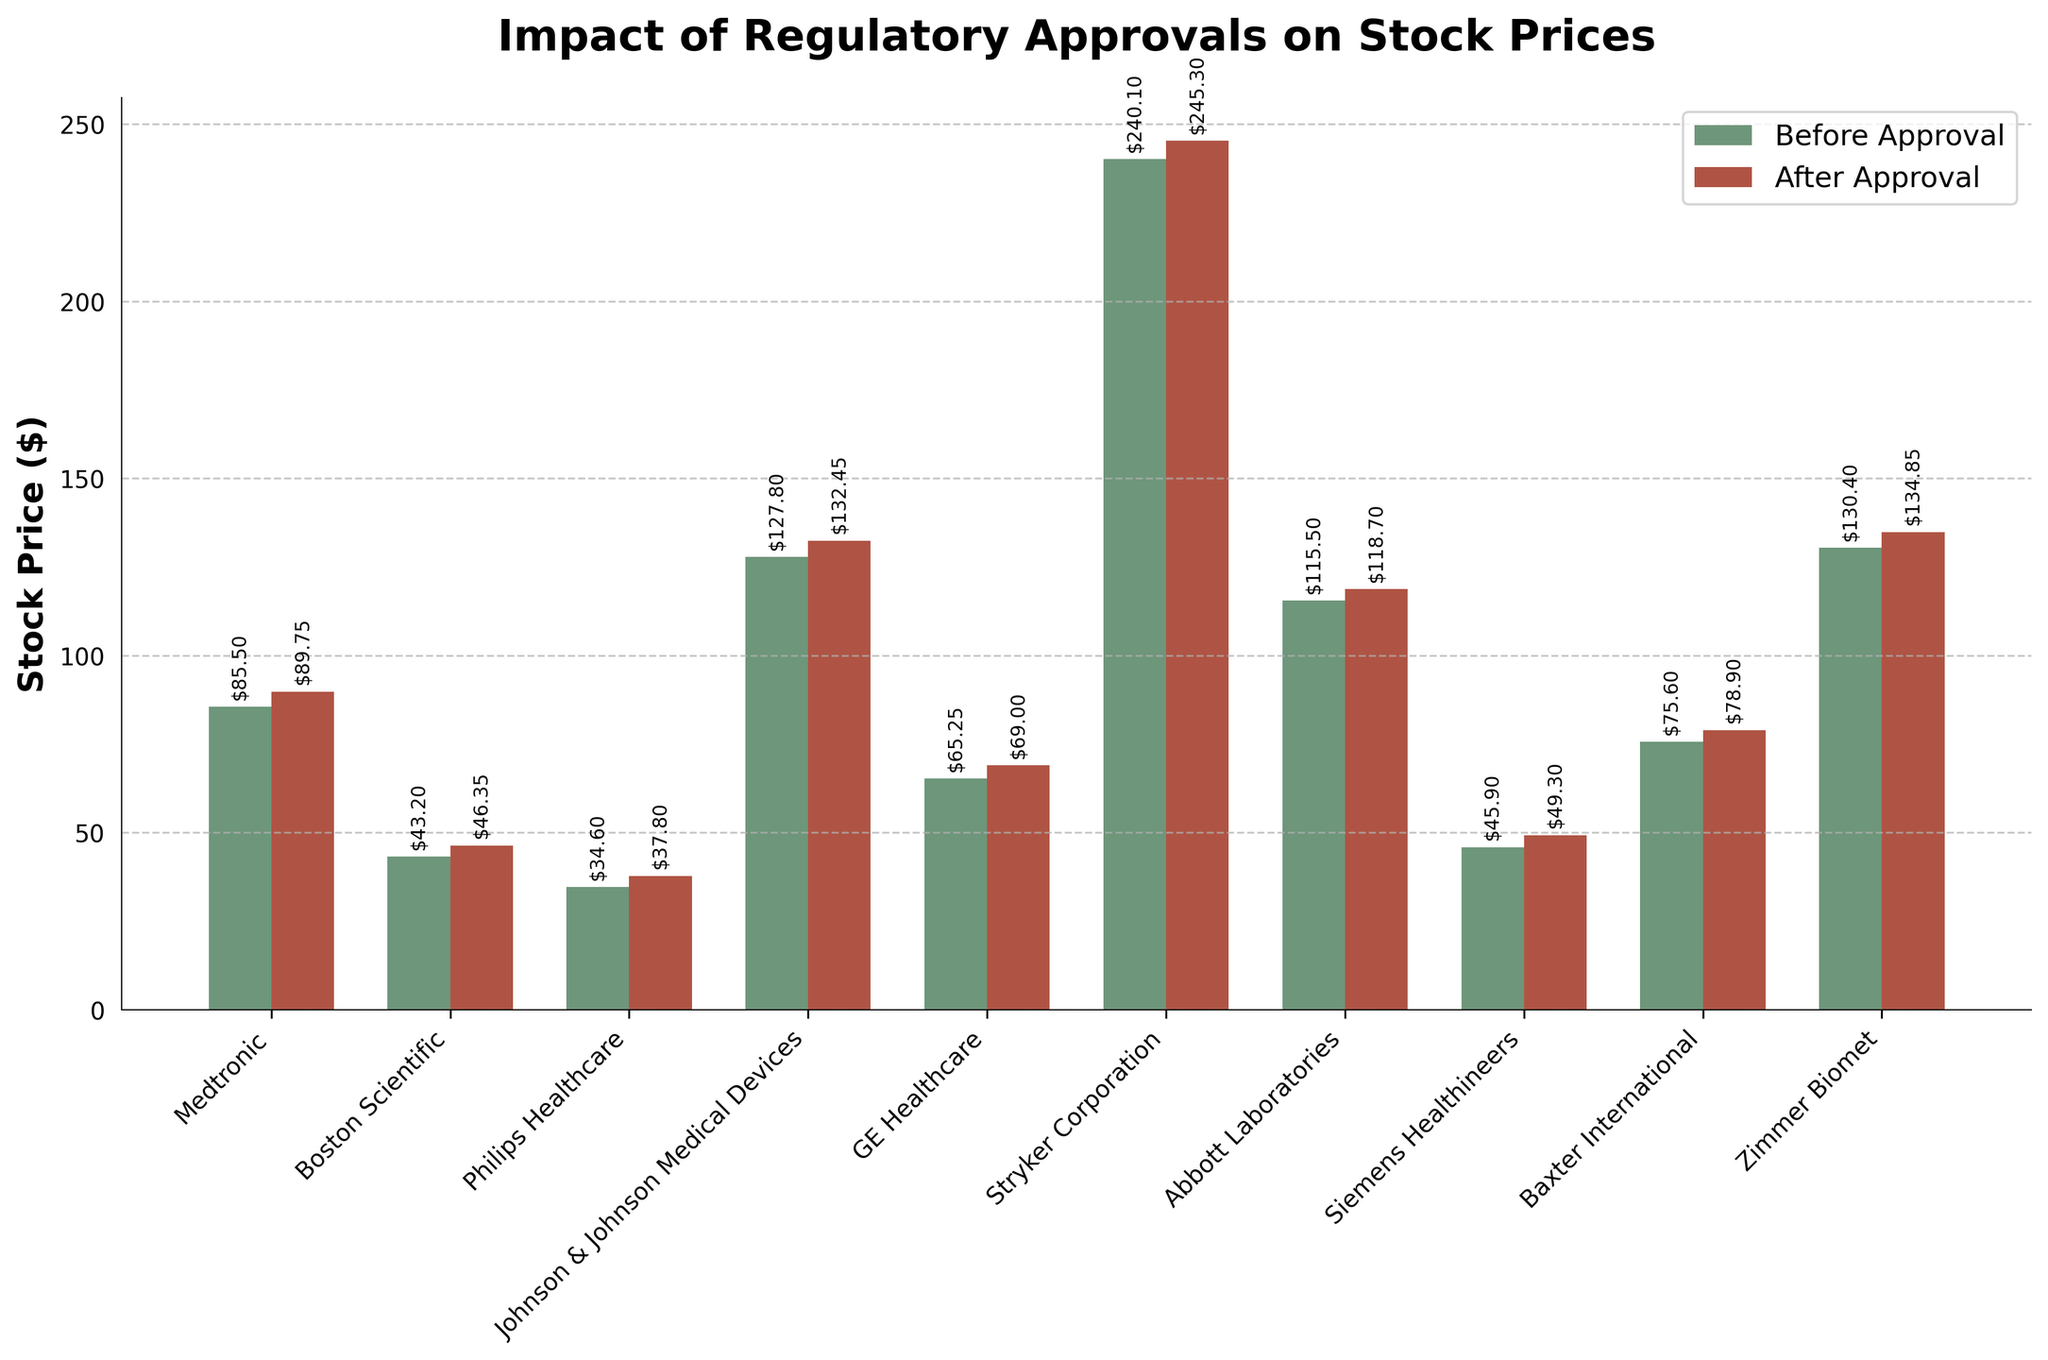What is the title of the plot? The title of the plot is generally found at the top center of the graph and describes what the plot represents. In this case, it reads "Impact of Regulatory Approvals on Stock Prices."
Answer: Impact of Regulatory Approvals on Stock Prices Which company's stock price increased by the largest amount after regulatory approval? To find this, subtract the 'StockPriceBeforeApproval' from the 'StockPriceAfterApproval' for each company and identify the maximum difference. The differences are: Medtronic: 4.25, Boston Scientific: 3.15, Philips Healthcare: 3.20, Johnson & Johnson Medical Devices: 4.65, GE Healthcare: 3.75, Stryker Corporation: 5.20, Abbott Laboratories: 3.20, Siemens Healthineers: 3.40, Baxter International: 3.30, Zimmer Biomet: 4.45.
Answer: Stryker Corporation What are the tick labels on the x-axis? The x-axis tick labels show the names of the companies involved, typically found at the bottom of the plot and are sometimes rotated for better visibility.
Answer: Medtronic, Boston Scientific, Philips Healthcare, Johnson & Johnson Medical Devices, GE Healthcare, Stryker Corporation, Abbott Laboratories, Siemens Healthineers, Baxter International, Zimmer Biomet Which company had the lowest stock price after regulatory approval? Review the 'StockPriceAfterApproval' values for each company and identify the minimum value. The 'StockPriceAfterApproval' values are: Medtronic: 89.75, Boston Scientific: 46.35, Philips Healthcare: 37.80, Johnson & Johnson Medical Devices: 132.45, GE Healthcare: 69.00, Stryker Corporation: 245.30, Abbott Laboratories: 118.70, Siemens Healthineers: 49.30, Baxter International: 78.90, Zimmer Biomet: 134.85.
Answer: Philips Healthcare How much did Johnson & Johnson Medical Devices' stock price increase after FDA approval in percentage? Calculate the percentage increase by using the formula: ((StockPriceAfterApproval - StockPriceBeforeApproval) / StockPriceBeforeApproval) * 100. For Johnson & Johnson Medical Devices, the values are: 132.45 (after) and 127.80 (before), so ((132.45-127.80) / 127.80) * 100 = 3.64%.
Answer: 3.64% How many companies received FDA approval according to the plot? Count the number of instances where the 'RegulatoryApproval' value is "FDA." The companies with FDA approval are: Medtronic, Boston Scientific, Johnson & Johnson Medical Devices, Stryker Corporation, Siemens Healthineers, Baxter International.
Answer: 6 What is the average stock price increase after regulatory approval for all companies? Calculate the increase for each company and find the average of these increases. The increases are: 4.25, 3.15, 3.20, 4.65, 3.75, 5.20, 3.20, 3.40, 3.30, 4.45. Sum these values: 38.55, and then divide by the number of companies, 10. So, 38.55 / 10 = 3.855.
Answer: 3.86 Which company's stock price had the smallest increase after regulatory approval? Determine the increases for each company and find the smallest value. The increases are: Medtronic: 4.25, Boston Scientific: 3.15, Philips Healthcare: 3.20, Johnson & Johnson Medical Devices: 4.65, GE Healthcare: 3.75, Stryker Corporation: 5.20, Abbott Laboratories: 3.20, Siemens Healthineers: 3.40, Baxter International: 3.30, Zimmer Biomet: 4.45.
Answer: Boston Scientific What is the overall trend seen in stock prices after regulatory approval? Observe the 'StockPriceBeforeApproval' and 'StockPriceAfterApproval' values across all companies; stock prices generally increase after receiving regulatory approval. This indicates a positive impact of regulatory approval on stock prices.
Answer: Prices generally increased Which regulatory body was associated with the highest average stock price increase post-approval? First, categorize the companies based on the regulatory body (FDA or EMA). Then calculate the average increases for each category. For FDA: Medtronic (4.25), Boston Scientific (3.15), Johnson & Johnson Medical Devices (4.65), Stryker Corporation (5.20), Siemens Healthineers (3.40), Baxter International (3.30). Sum of increases is 23.95 from 6 companies, so average is 23.95/6 = 3.99. For EMA: Philips Healthcare (3.20), GE Healthcare (3.75), Abbott Laboratories (3.20), Zimmer Biomet (4.45). Sum of increases is 14.60 from 4 companies, so average is 14.60/4 = 3.65.
Answer: FDA 